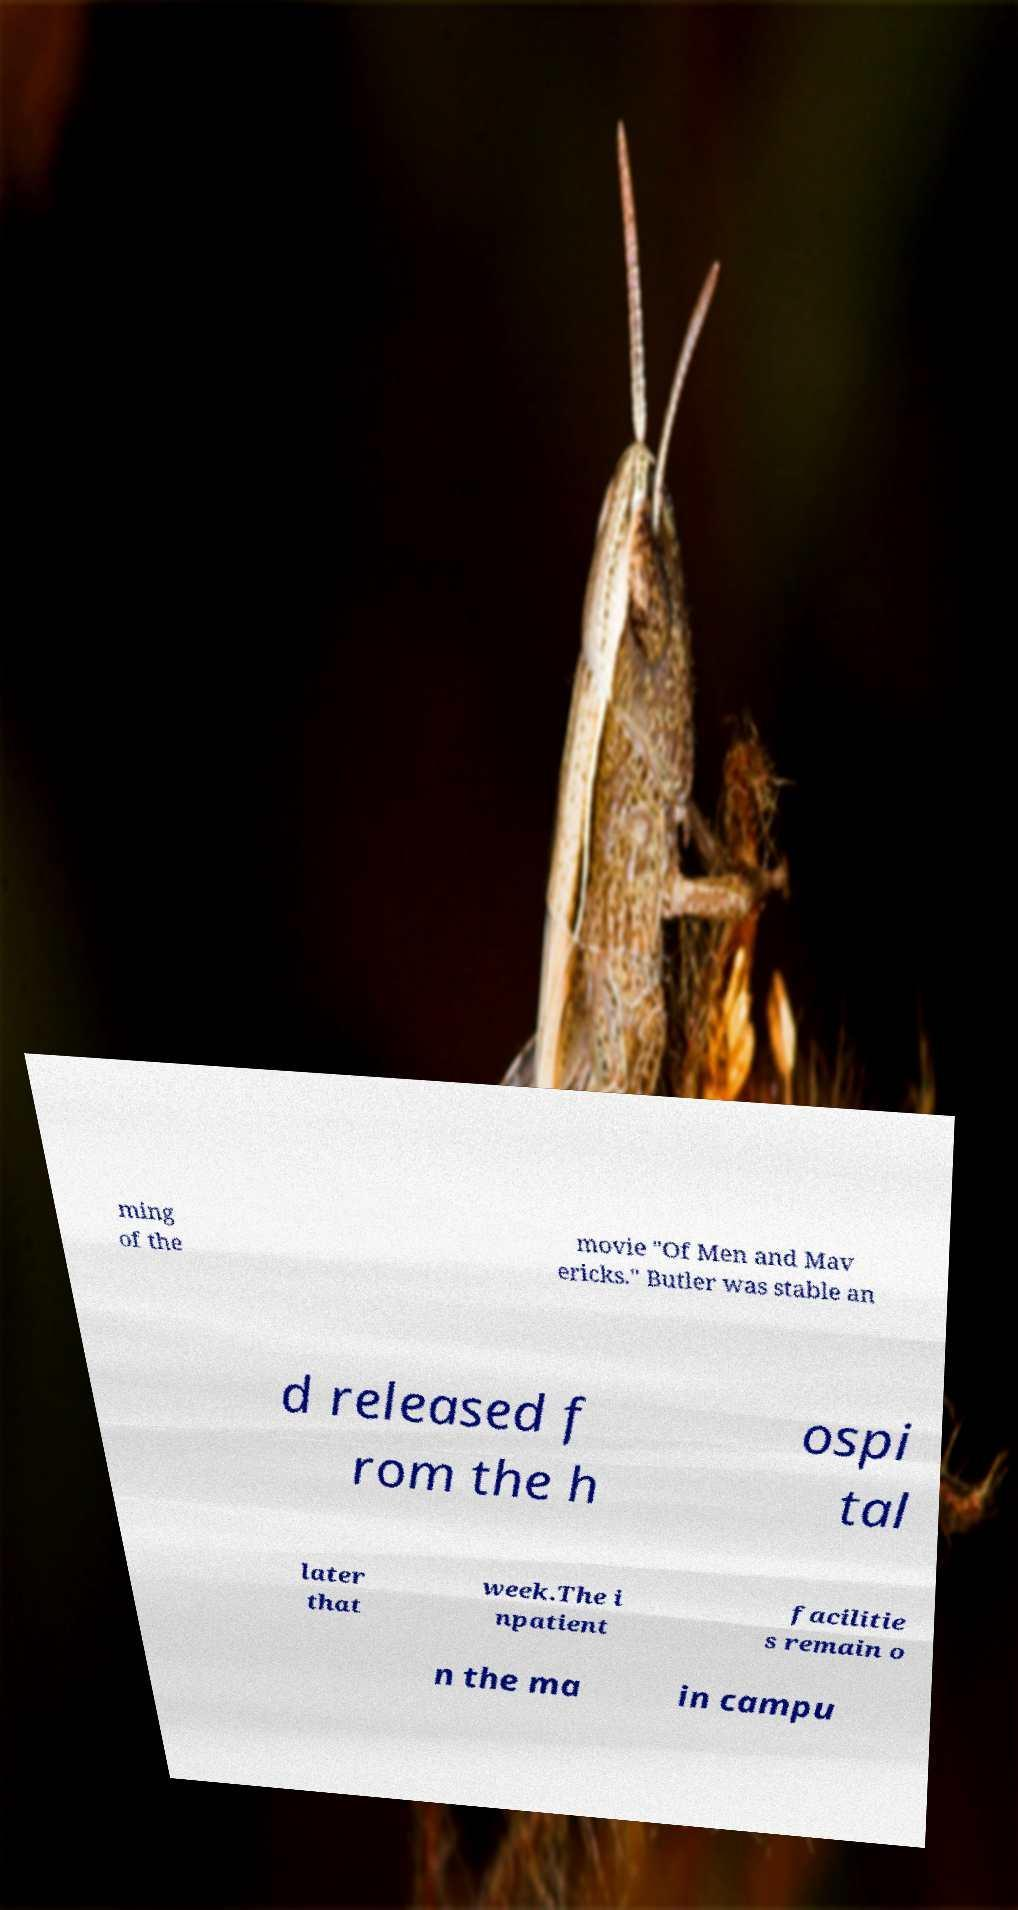I need the written content from this picture converted into text. Can you do that? ming of the movie "Of Men and Mav ericks." Butler was stable an d released f rom the h ospi tal later that week.The i npatient facilitie s remain o n the ma in campu 